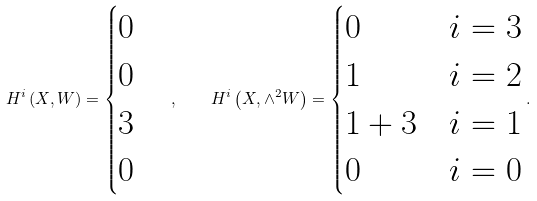Convert formula to latex. <formula><loc_0><loc_0><loc_500><loc_500>H ^ { i } \left ( X , W \right ) = \begin{cases} 0 \\ 0 \\ 3 \\ 0 \end{cases} , \quad H ^ { i } \left ( X , \wedge ^ { 2 } W \right ) = \begin{cases} 0 & i = 3 \\ 1 & i = 2 \\ 1 + 3 & i = 1 \\ 0 & i = 0 \\ \end{cases} .</formula> 